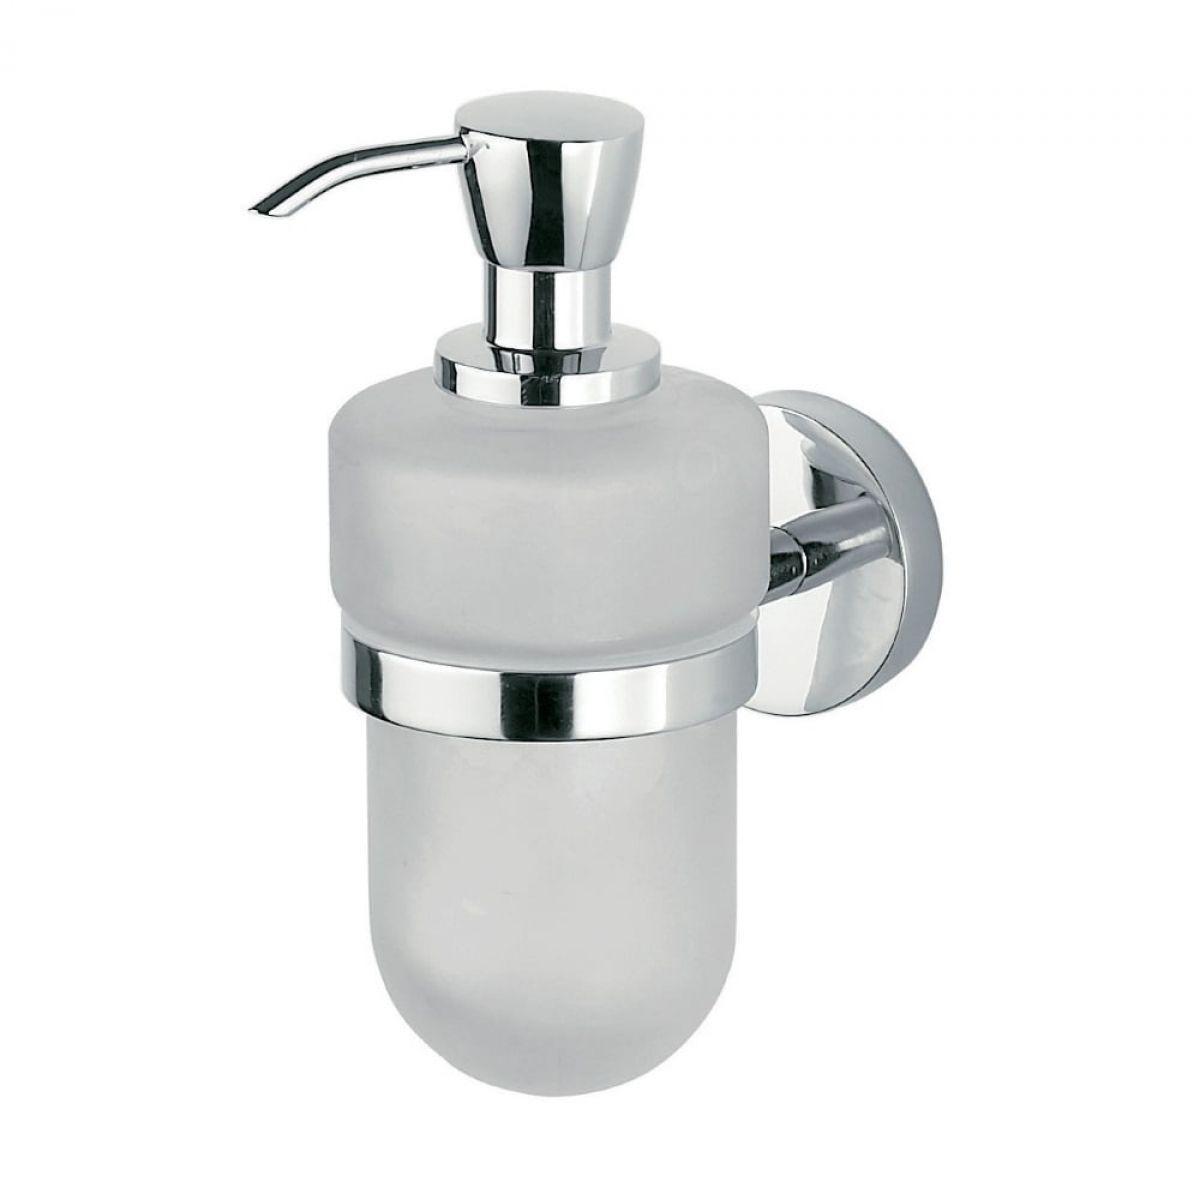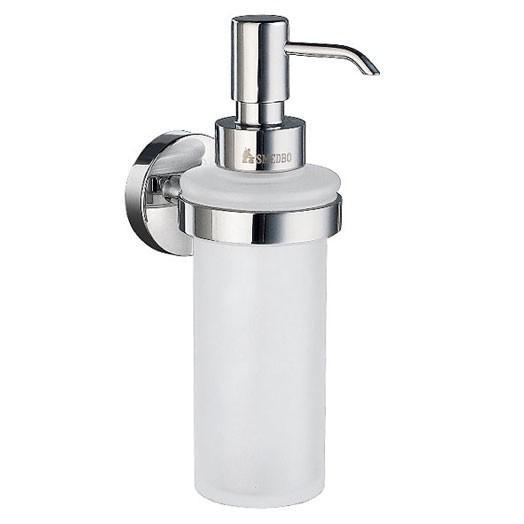The first image is the image on the left, the second image is the image on the right. Given the left and right images, does the statement "The left and right image contains the same number of wall hanging soap dispensers." hold true? Answer yes or no. Yes. The first image is the image on the left, the second image is the image on the right. Analyze the images presented: Is the assertion "Each image contains one cylindrical pump-top dispenser that mounts alone on a wall and has a chrome top and narrow band around it." valid? Answer yes or no. Yes. 